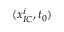<formula> <loc_0><loc_0><loc_500><loc_500>( x _ { I C } ^ { i } , t _ { 0 } )</formula> 